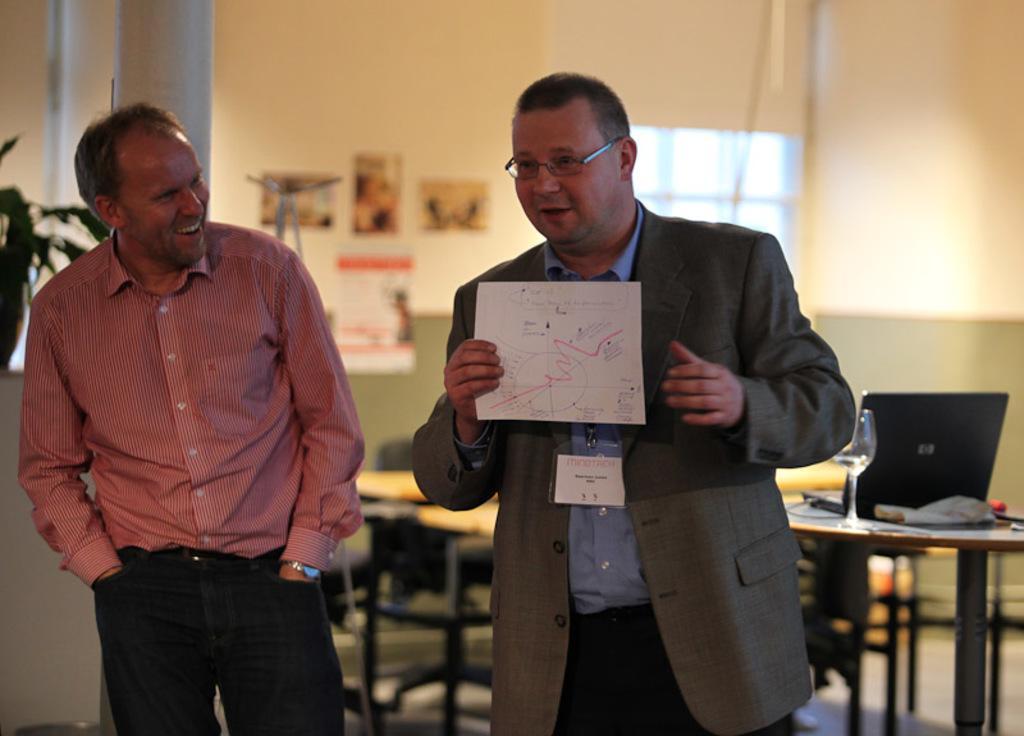Could you give a brief overview of what you see in this image? In this image we can see two men. Here we can see a man on the right side is wearing a suit and he is holding the paper in his right hand. Here we can see a man on the left side is smiling. Here we can see a laptop and a glass on the table. In the background, we can see the table and chair. 